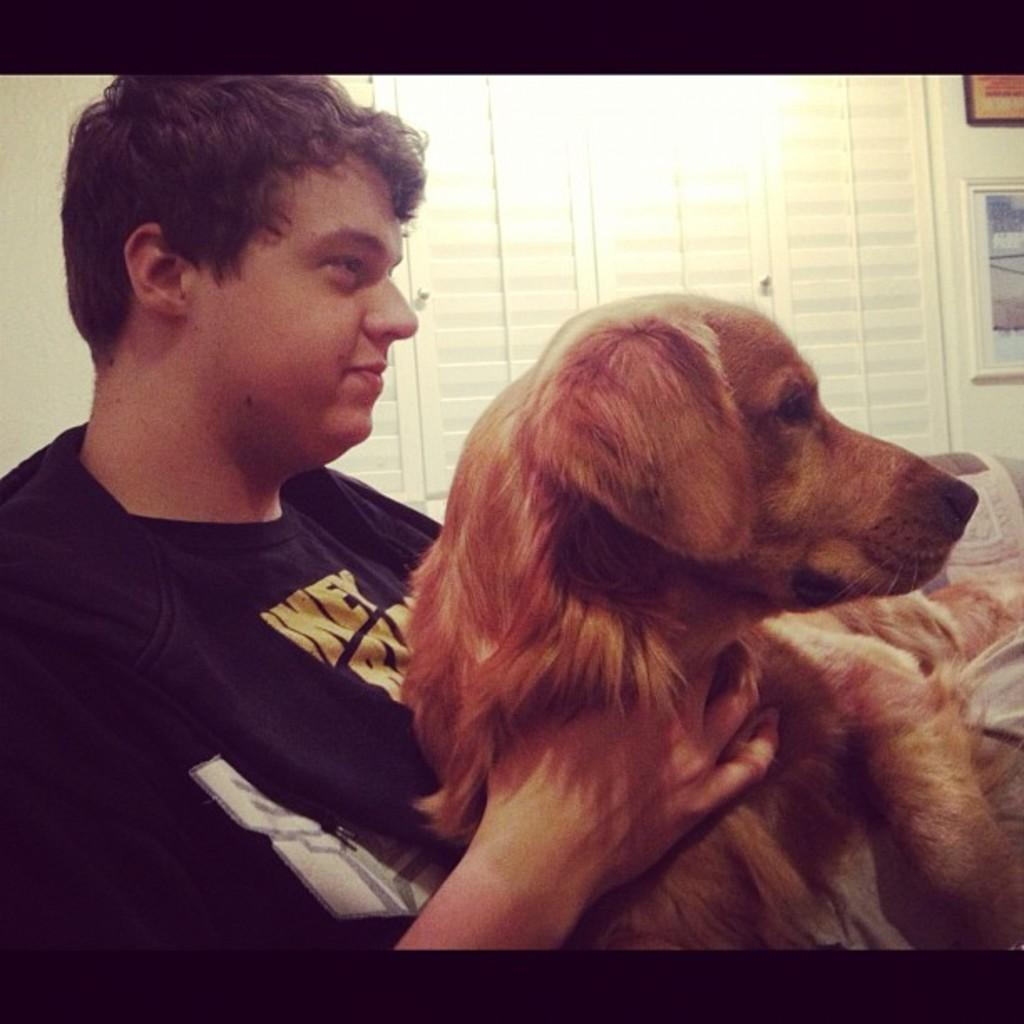Who is present in the image? There is a man in the image. What is the man wearing? The man is wearing a black t-shirt. What is the man holding in the image? The man is holding a brown dog. What can be seen in the background of the image? There are doors, a wall, and photo frames in the background of the image. How does the man's elbow feel in the image? There is no information about the man's elbow in the image, so it cannot be determined how it feels. 